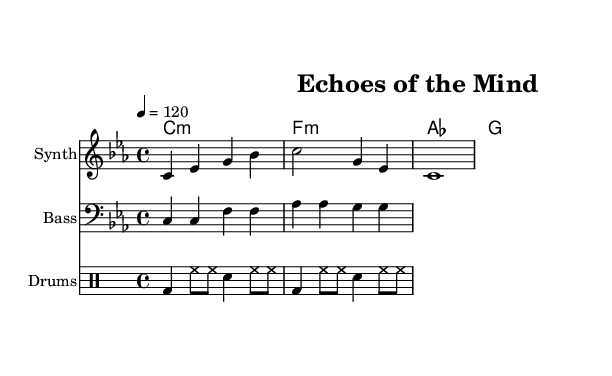What is the key signature of this music? The key signature is C minor, which has three flats: B flat, E flat, and A flat.
Answer: C minor What is the time signature of this music? The time signature is indicated at the beginning of the piece; it shows 4 beats per measure.
Answer: 4/4 What is the tempo marking? The tempo marking indicates a speed of 120 beats per minute, as specified at the start of the score.
Answer: 120 How many measures are in the synthesizer part? By counting the groups of notes in the synthesizer's section, there are four measures present in this part.
Answer: 4 Which instruments are included in this score? The score lists three different instruments: Synth, Bass, and Drums, each indicated in separate staves.
Answer: Synth, Bass, Drums What type of chords are used in this piece? The chords in the chord names section are minor and major chords, specifically the minor chords C minor, F minor, and the major chords A flat and G major.
Answer: Minor and Major How does the rhythm of the drum patterns contribute to the dance genre? The drum patterns consist of a kick drum, hi-hats, and snare, creating a driving rhythm that is characteristic of dance music.
Answer: Driving rhythm 